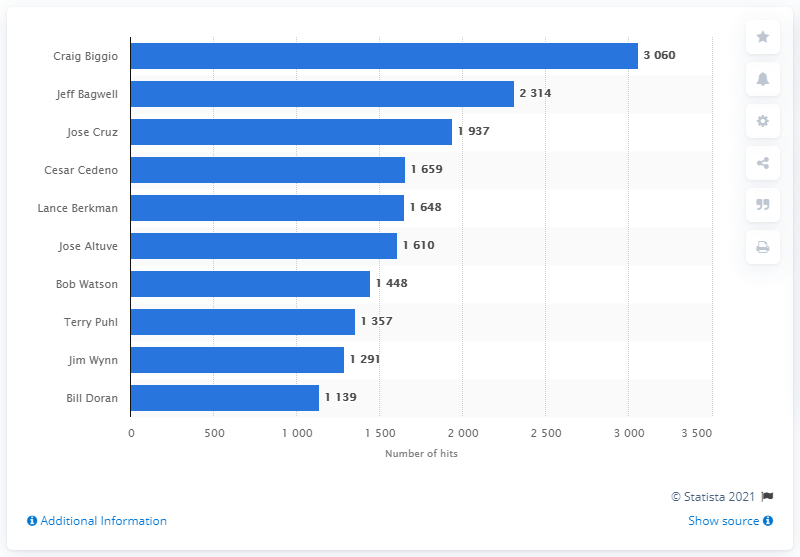Give some essential details in this illustration. The Houston Astros franchise history has been dominated by Craig Biggio, who boasts the most hits in the team's record books. 